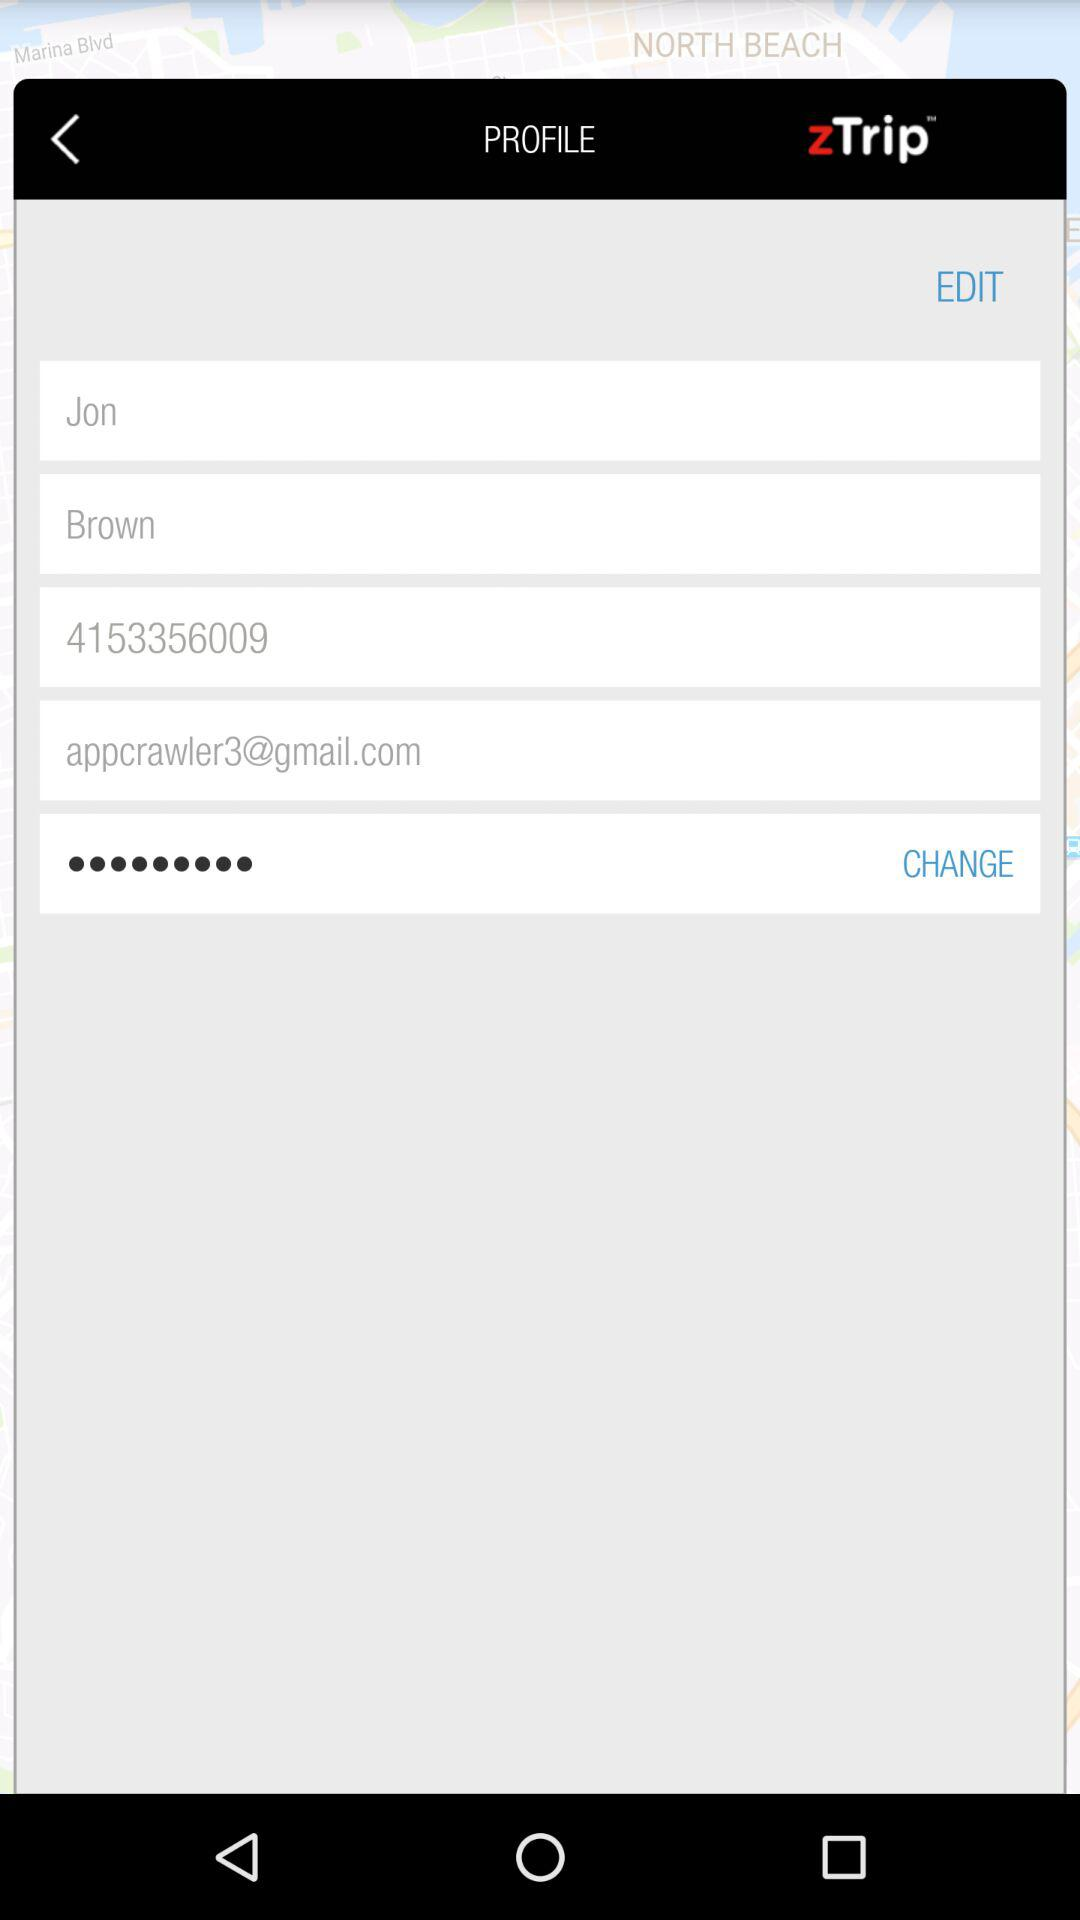Where is Jon Brown located?
When the provided information is insufficient, respond with <no answer>. <no answer> 